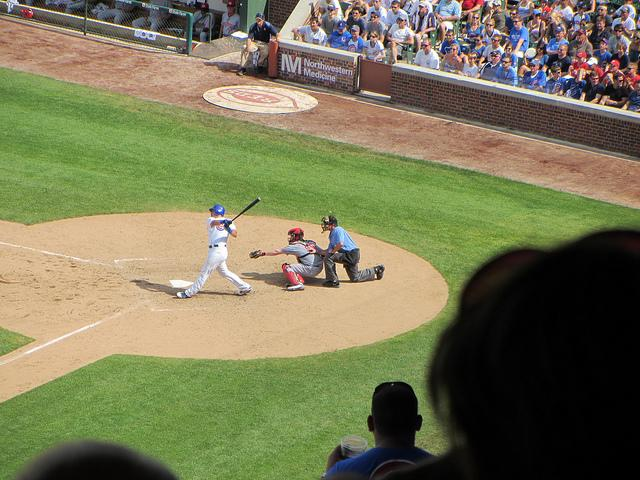What does Northwestern Medicine provide in this game? Please explain your reasoning. sponsor. There is a northwestern medicine sign near the dugout. this company paid to put the sign there. 